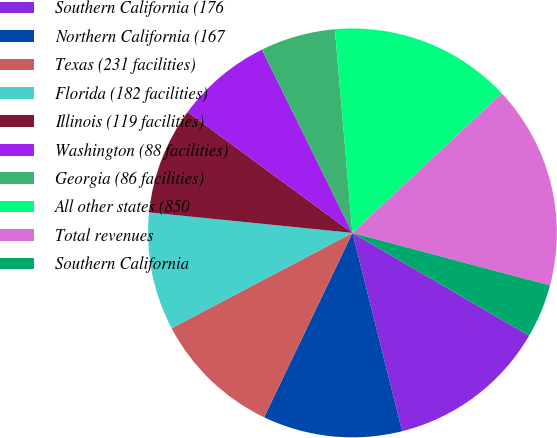Convert chart to OTSL. <chart><loc_0><loc_0><loc_500><loc_500><pie_chart><fcel>Southern California (176<fcel>Northern California (167<fcel>Texas (231 facilities)<fcel>Florida (182 facilities)<fcel>Illinois (119 facilities)<fcel>Washington (88 facilities)<fcel>Georgia (86 facilities)<fcel>All other states (850<fcel>Total revenues<fcel>Southern California<nl><fcel>12.71%<fcel>11.02%<fcel>10.17%<fcel>9.32%<fcel>8.47%<fcel>7.63%<fcel>5.93%<fcel>14.41%<fcel>16.1%<fcel>4.24%<nl></chart> 